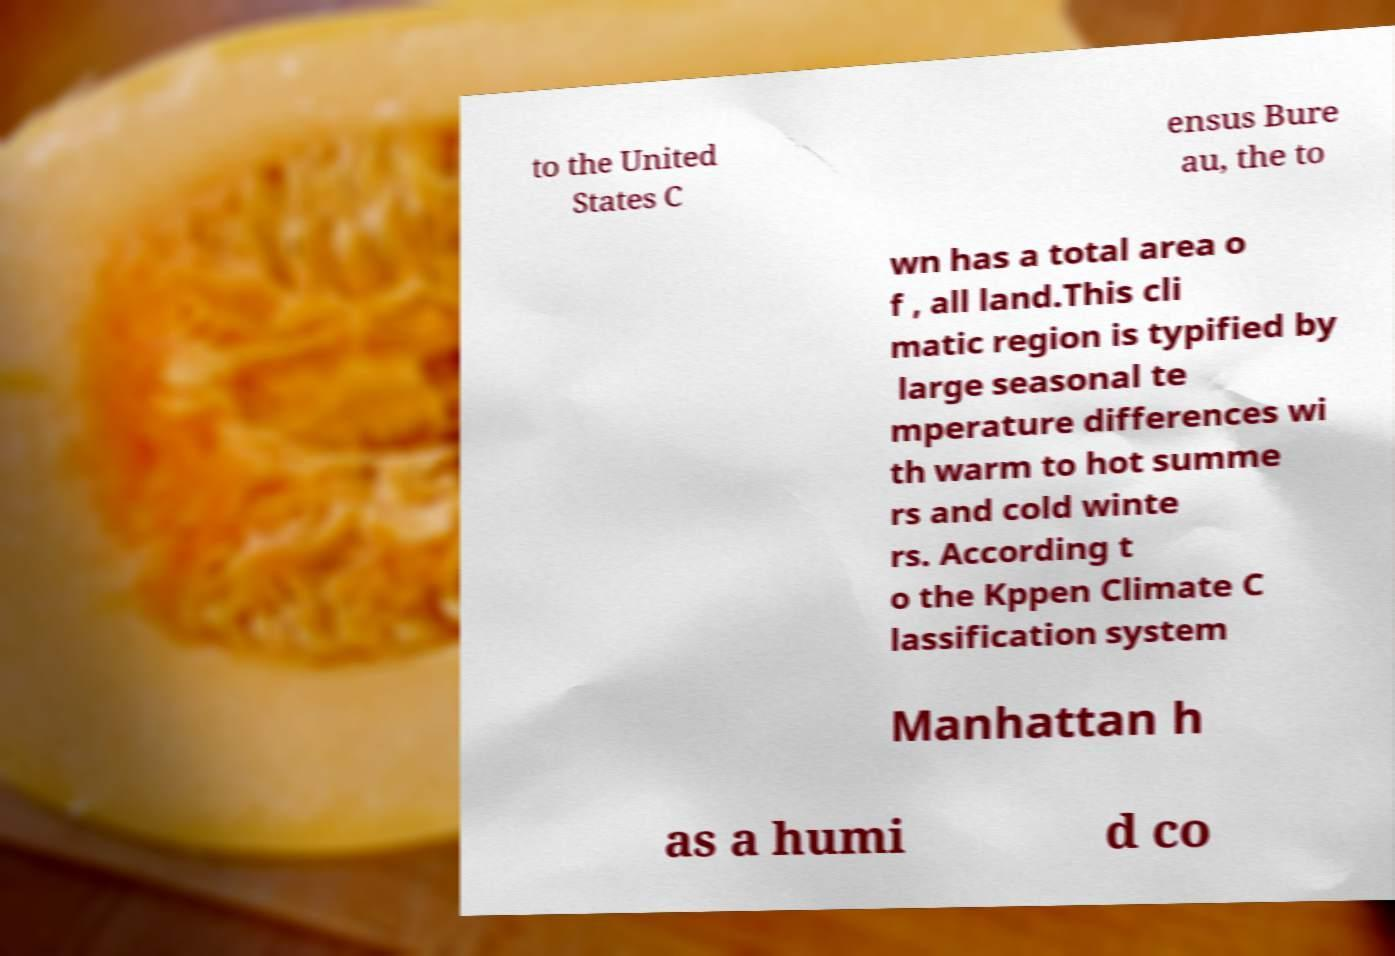Could you extract and type out the text from this image? to the United States C ensus Bure au, the to wn has a total area o f , all land.This cli matic region is typified by large seasonal te mperature differences wi th warm to hot summe rs and cold winte rs. According t o the Kppen Climate C lassification system Manhattan h as a humi d co 